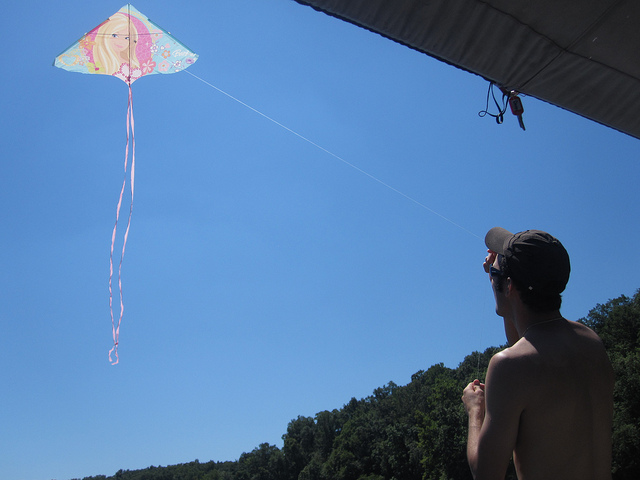Are there any notable features in the landscape besides the kite? The landscape includes a dense treeline, which forms a lush, natural backdrop for the kite flying. The clear skies complement the tree line, creating a serene setting that goes beyond the immediate thrill of the kite. 